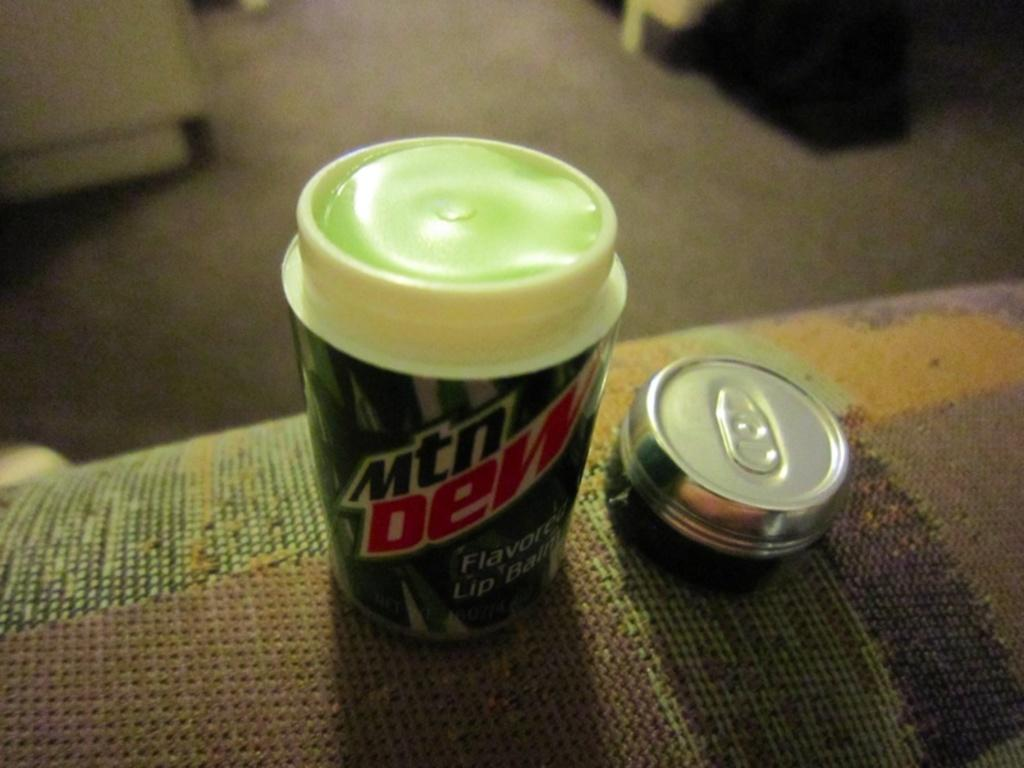<image>
Provide a brief description of the given image. A mtn dew cup with lid and a silver and black can beside it. 